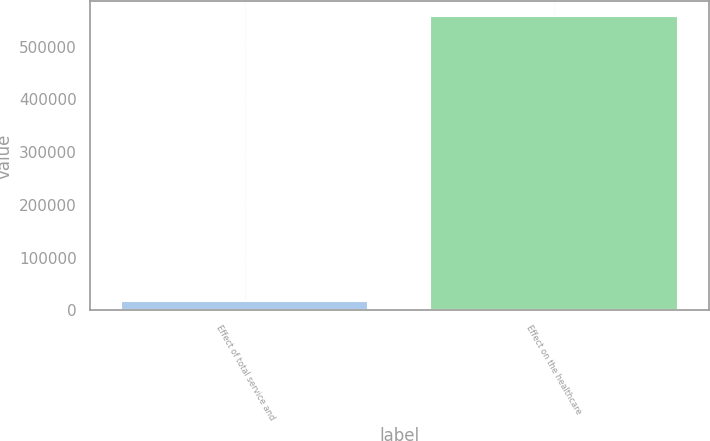Convert chart. <chart><loc_0><loc_0><loc_500><loc_500><bar_chart><fcel>Effect of total service and<fcel>Effect on the healthcare<nl><fcel>17605<fcel>557729<nl></chart> 